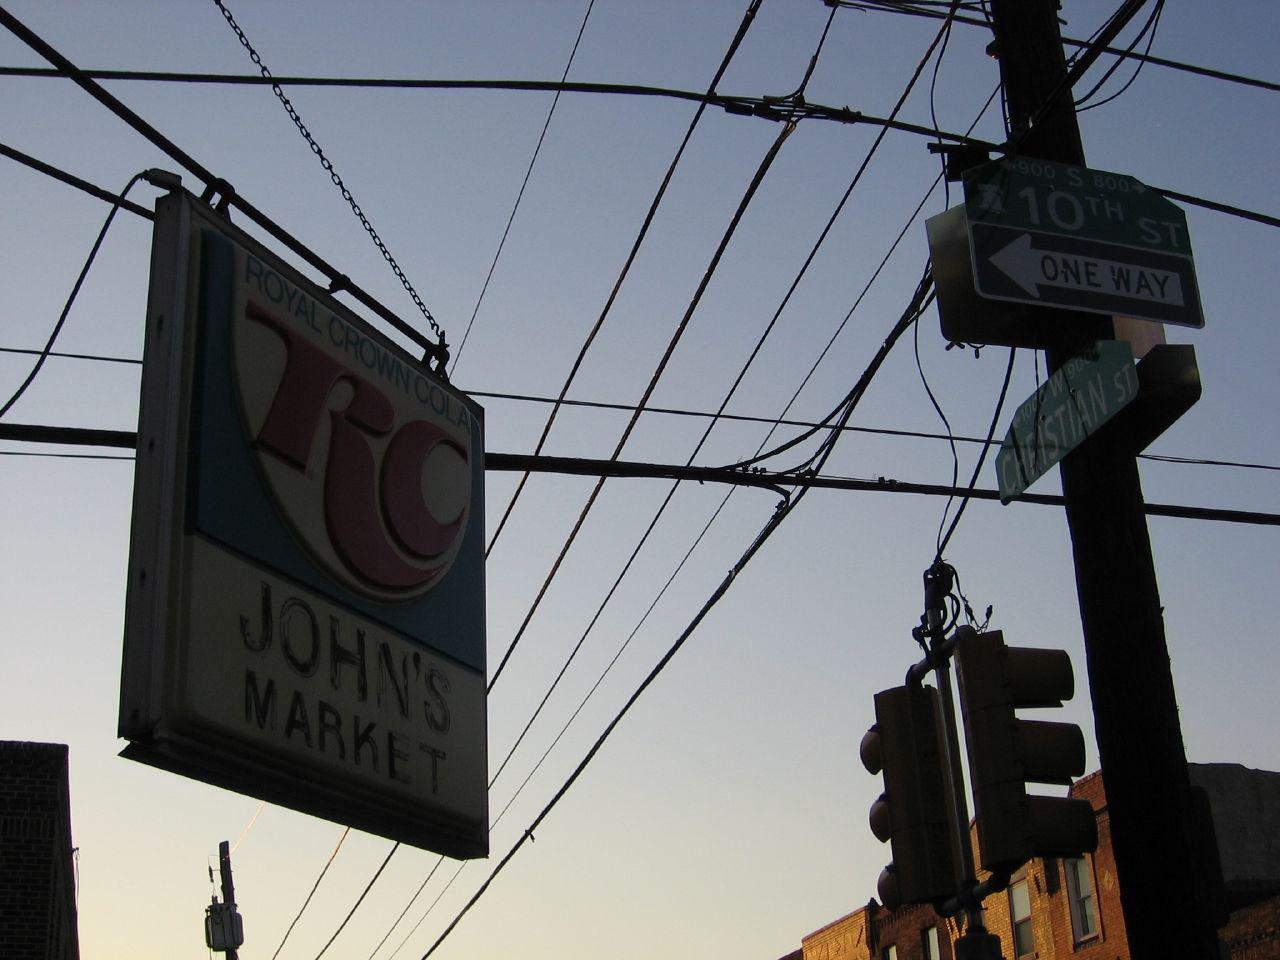Question: why is the sign pointing there?
Choices:
A. For the citizens.
B. For directions.
C. For everyone.
D. For pedestrians.
Answer with the letter. Answer: A Question: what is the other sign saying?
Choices:
A. Jim's seafood.
B. Mike's carwash.
C. Jack's diner.
D. John's market.
Answer with the letter. Answer: D Question: how can one tell there is a market nearby?
Choices:
A. The sign.
B. The smell.
C. The shoppers.
D. The activity.
Answer with the letter. Answer: A Question: what other object is in the picture?
Choices:
A. Telephone wires.
B. Trains.
C. Cars.
D. Electric poles.
Answer with the letter. Answer: D Question: how many traffic lights are there?
Choices:
A. Two.
B. One.
C. None.
D. Six.
Answer with the letter. Answer: A Question: how many directions can you go on 10th street?
Choices:
A. One.
B. Two.
C. Four.
D. North and South.
Answer with the letter. Answer: A Question: what does the sky look like?
Choices:
A. Cloudy.
B. Overcast.
C. Clear.
D. Dark.
Answer with the letter. Answer: C Question: what is the street along the way?
Choices:
A. Woodly street.
B. Windview street.
C. Christian street.
D. Windhock street.
Answer with the letter. Answer: C Question: what is in the background?
Choices:
A. A building.
B. A car.
C. Sheep.
D. Cows.
Answer with the letter. Answer: A Question: where is the picture taken?
Choices:
A. The car.
B. At an intersection.
C. The lark cage.
D. The zoo.
Answer with the letter. Answer: B Question: what does the bottom of the rc sign say?
Choices:
A. John's market.
B. Kroger.
C. Deer crossing.
D. Library.
Answer with the letter. Answer: A Question: where is john's market written?
Choices:
A. On the t-shirt.
B. On the rc sign.
C. On the receipt.
D. On the shopping cart.
Answer with the letter. Answer: B Question: what colors are the rc sign?
Choices:
A. Red, blue, black, and white.
B. Yellow and Green.
C. Blue and Red.
D. Purple and Orange.
Answer with the letter. Answer: A Question: what can be seen facing different directions?
Choices:
A. The street light.
B. The two cars.
C. The mirrors in the fun house.
D. The street signs.
Answer with the letter. Answer: A Question: how many traffic lights are there?
Choices:
A. Six.
B. Four.
C. Two.
D. Eight.
Answer with the letter. Answer: C Question: what way is the white arrow pointing?
Choices:
A. Right.
B. Left.
C. Up.
D. Down.
Answer with the letter. Answer: B 